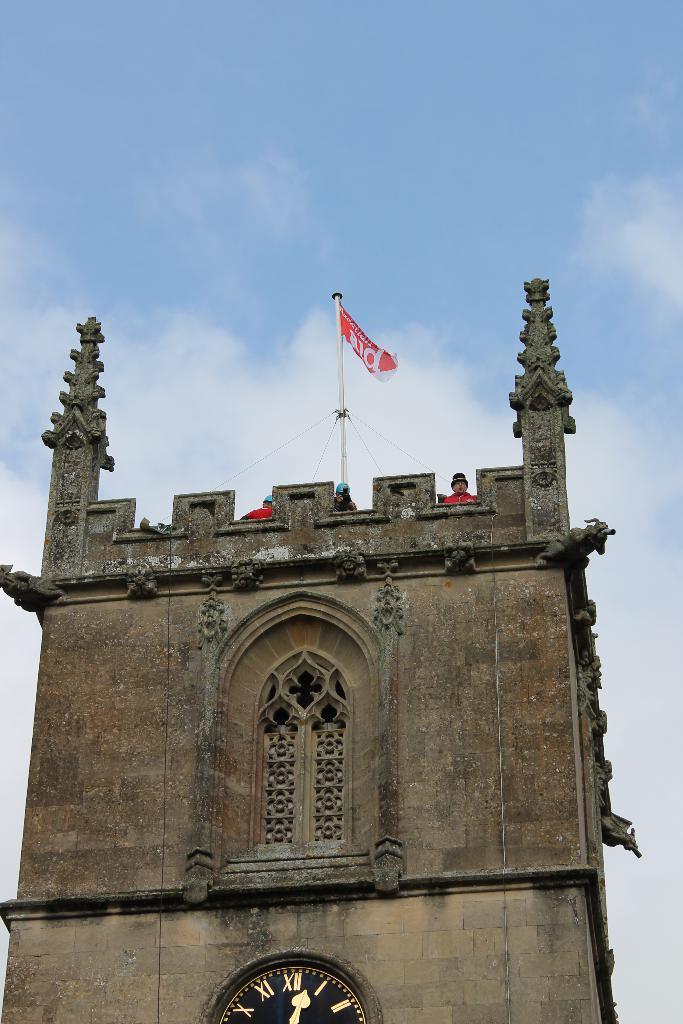How would you summarize this image in a sentence or two? In this image I can see the building and I can also see three persons and the flag. In the background I can see the sky in white and blue color. 